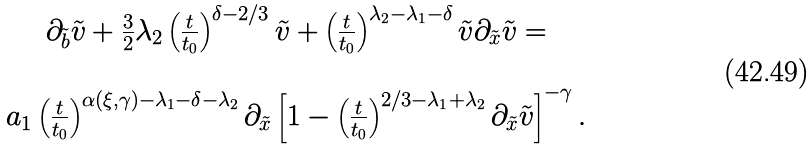Convert formula to latex. <formula><loc_0><loc_0><loc_500><loc_500>\begin{array} { c } \partial _ { \tilde { b } } \tilde { v } + \frac { 3 } { 2 } \lambda _ { 2 } \left ( \frac { t } { t _ { 0 } } \right ) ^ { \delta - 2 / 3 } \tilde { v } + \left ( \frac { t } { t _ { 0 } } \right ) ^ { \lambda _ { 2 } - \lambda _ { 1 } - \delta } \tilde { v } \partial _ { \tilde { x } } \tilde { v } = \\ \\ a _ { 1 } \left ( \frac { t } { t _ { 0 } } \right ) ^ { \alpha ( \xi , \gamma ) - \lambda _ { 1 } - \delta - \lambda _ { 2 } } \partial _ { \tilde { x } } \left [ 1 - \left ( \frac { t } { t _ { 0 } } \right ) ^ { 2 / 3 - \lambda _ { 1 } + \lambda _ { 2 } } \partial _ { \tilde { x } } \tilde { v } \right ] ^ { - \gamma } . \end{array}</formula> 